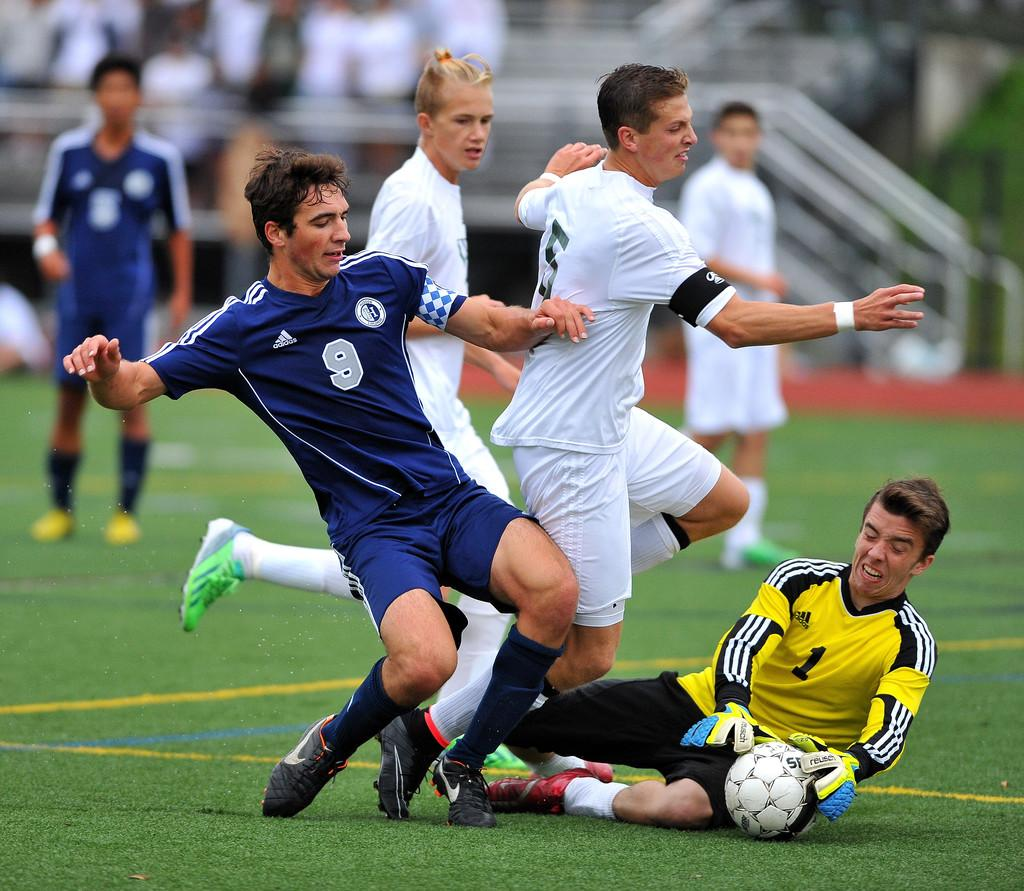What is happening in the image involving a group of people? The people in the image are playing a game. Can you describe the appearance of one of the individuals in the group? One person is wearing a blue dress. What can be observed about the background of the image? The background of the image is blurred. What type of meat is being served on the wheel in the image? There is no meat or wheel present in the image. 